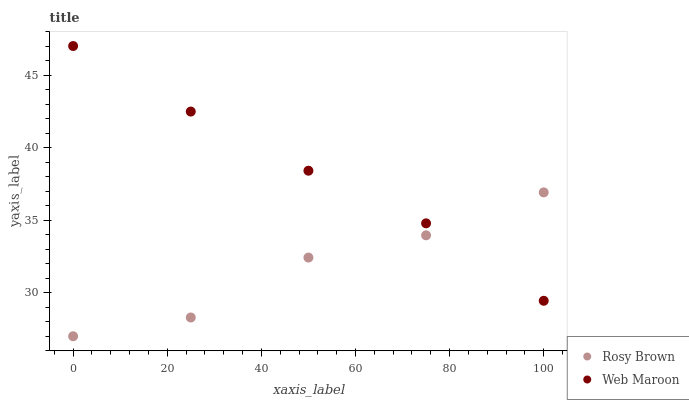Does Rosy Brown have the minimum area under the curve?
Answer yes or no. Yes. Does Web Maroon have the maximum area under the curve?
Answer yes or no. Yes. Does Web Maroon have the minimum area under the curve?
Answer yes or no. No. Is Web Maroon the smoothest?
Answer yes or no. Yes. Is Rosy Brown the roughest?
Answer yes or no. Yes. Is Web Maroon the roughest?
Answer yes or no. No. Does Rosy Brown have the lowest value?
Answer yes or no. Yes. Does Web Maroon have the lowest value?
Answer yes or no. No. Does Web Maroon have the highest value?
Answer yes or no. Yes. Does Rosy Brown intersect Web Maroon?
Answer yes or no. Yes. Is Rosy Brown less than Web Maroon?
Answer yes or no. No. Is Rosy Brown greater than Web Maroon?
Answer yes or no. No. 